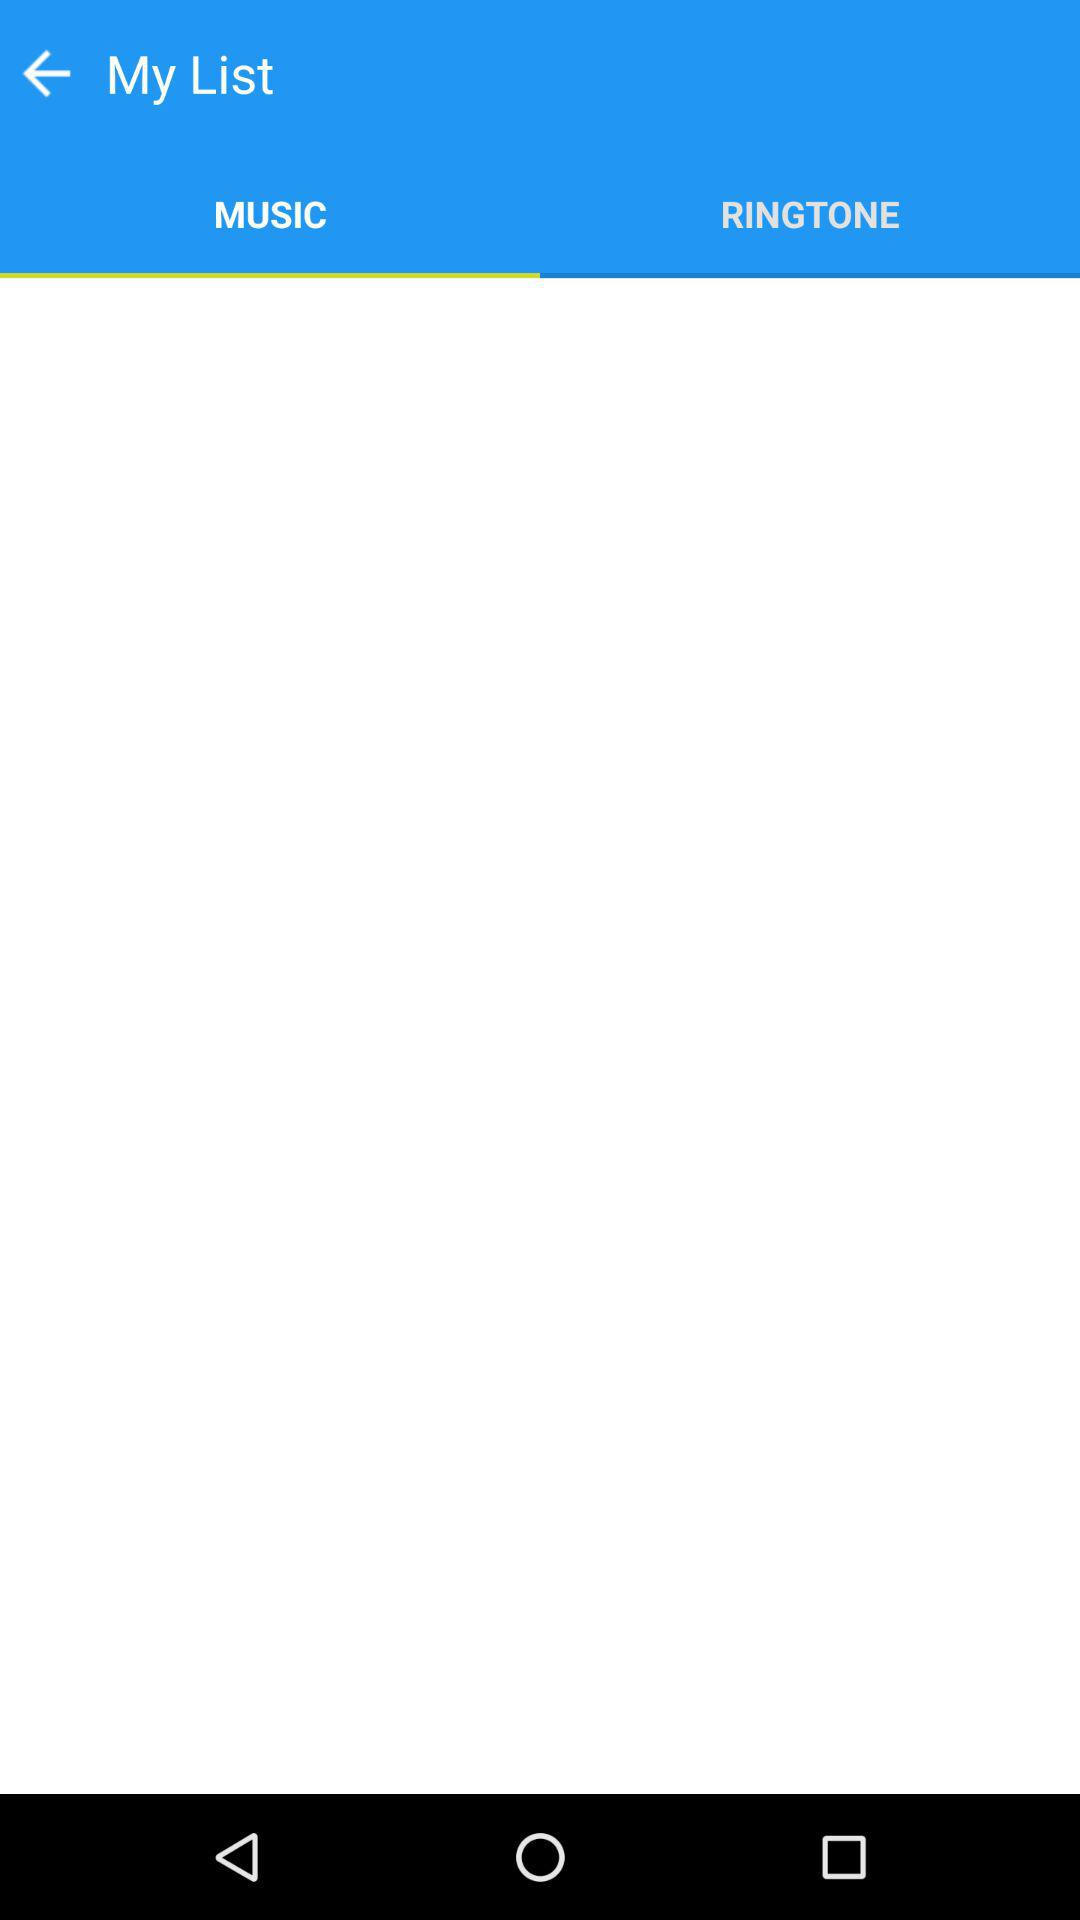Which tab is selected? The selected tab is "MUSIC". 